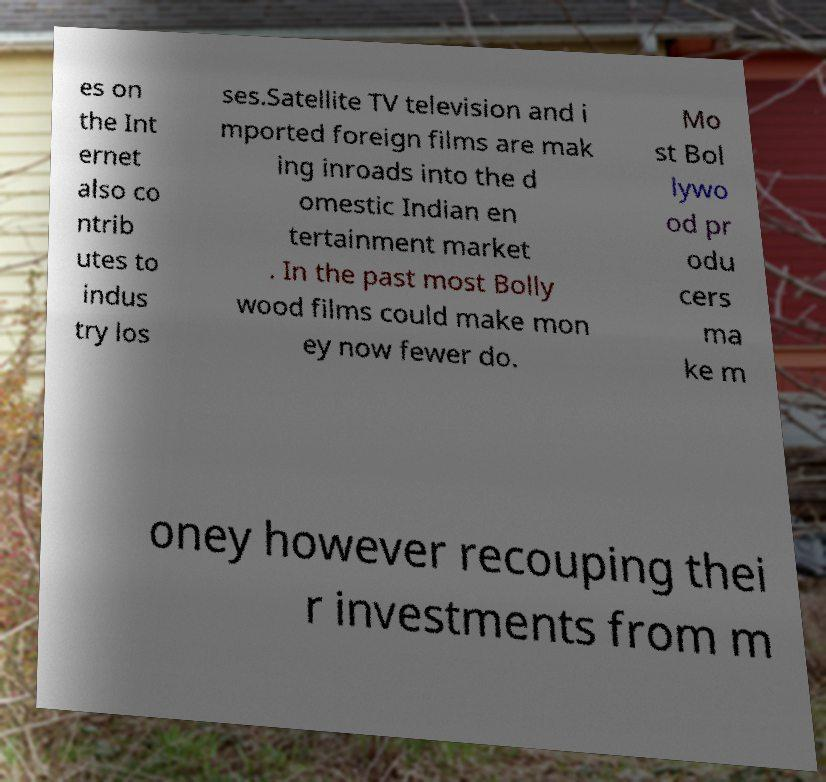What messages or text are displayed in this image? I need them in a readable, typed format. es on the Int ernet also co ntrib utes to indus try los ses.Satellite TV television and i mported foreign films are mak ing inroads into the d omestic Indian en tertainment market . In the past most Bolly wood films could make mon ey now fewer do. Mo st Bol lywo od pr odu cers ma ke m oney however recouping thei r investments from m 